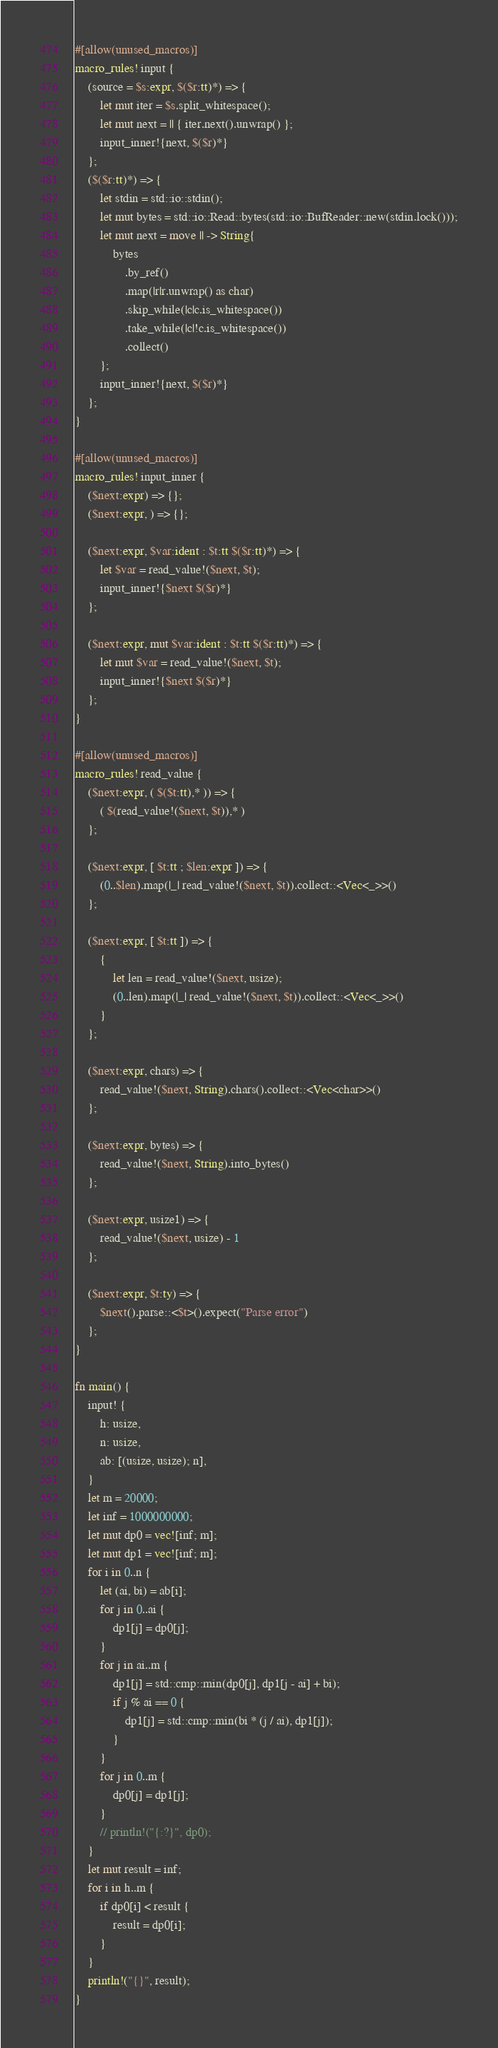Convert code to text. <code><loc_0><loc_0><loc_500><loc_500><_Rust_>#[allow(unused_macros)]
macro_rules! input {
    (source = $s:expr, $($r:tt)*) => {
        let mut iter = $s.split_whitespace();
        let mut next = || { iter.next().unwrap() };
        input_inner!{next, $($r)*}
    };
    ($($r:tt)*) => {
        let stdin = std::io::stdin();
        let mut bytes = std::io::Read::bytes(std::io::BufReader::new(stdin.lock()));
        let mut next = move || -> String{
            bytes
                .by_ref()
                .map(|r|r.unwrap() as char)
                .skip_while(|c|c.is_whitespace())
                .take_while(|c|!c.is_whitespace())
                .collect()
        };
        input_inner!{next, $($r)*}
    };
}

#[allow(unused_macros)]
macro_rules! input_inner {
    ($next:expr) => {};
    ($next:expr, ) => {};

    ($next:expr, $var:ident : $t:tt $($r:tt)*) => {
        let $var = read_value!($next, $t);
        input_inner!{$next $($r)*}
    };

    ($next:expr, mut $var:ident : $t:tt $($r:tt)*) => {
        let mut $var = read_value!($next, $t);
        input_inner!{$next $($r)*}
    };
}

#[allow(unused_macros)]
macro_rules! read_value {
    ($next:expr, ( $($t:tt),* )) => {
        ( $(read_value!($next, $t)),* )
    };

    ($next:expr, [ $t:tt ; $len:expr ]) => {
        (0..$len).map(|_| read_value!($next, $t)).collect::<Vec<_>>()
    };

    ($next:expr, [ $t:tt ]) => {
        {
            let len = read_value!($next, usize);
            (0..len).map(|_| read_value!($next, $t)).collect::<Vec<_>>()
        }
    };

    ($next:expr, chars) => {
        read_value!($next, String).chars().collect::<Vec<char>>()
    };

    ($next:expr, bytes) => {
        read_value!($next, String).into_bytes()
    };

    ($next:expr, usize1) => {
        read_value!($next, usize) - 1
    };

    ($next:expr, $t:ty) => {
        $next().parse::<$t>().expect("Parse error")
    };
}

fn main() {
    input! {
        h: usize,
        n: usize,
        ab: [(usize, usize); n],
    }
    let m = 20000;
    let inf = 1000000000;
    let mut dp0 = vec![inf; m];
    let mut dp1 = vec![inf; m];
    for i in 0..n {
        let (ai, bi) = ab[i];
        for j in 0..ai {
            dp1[j] = dp0[j];
        }
        for j in ai..m {
            dp1[j] = std::cmp::min(dp0[j], dp1[j - ai] + bi);
            if j % ai == 0 {
                dp1[j] = std::cmp::min(bi * (j / ai), dp1[j]);
            }
        }
        for j in 0..m {
            dp0[j] = dp1[j];
        }
        // println!("{:?}", dp0);
    }
    let mut result = inf;
    for i in h..m {
        if dp0[i] < result {
            result = dp0[i];
        }
    }
    println!("{}", result);
}
</code> 